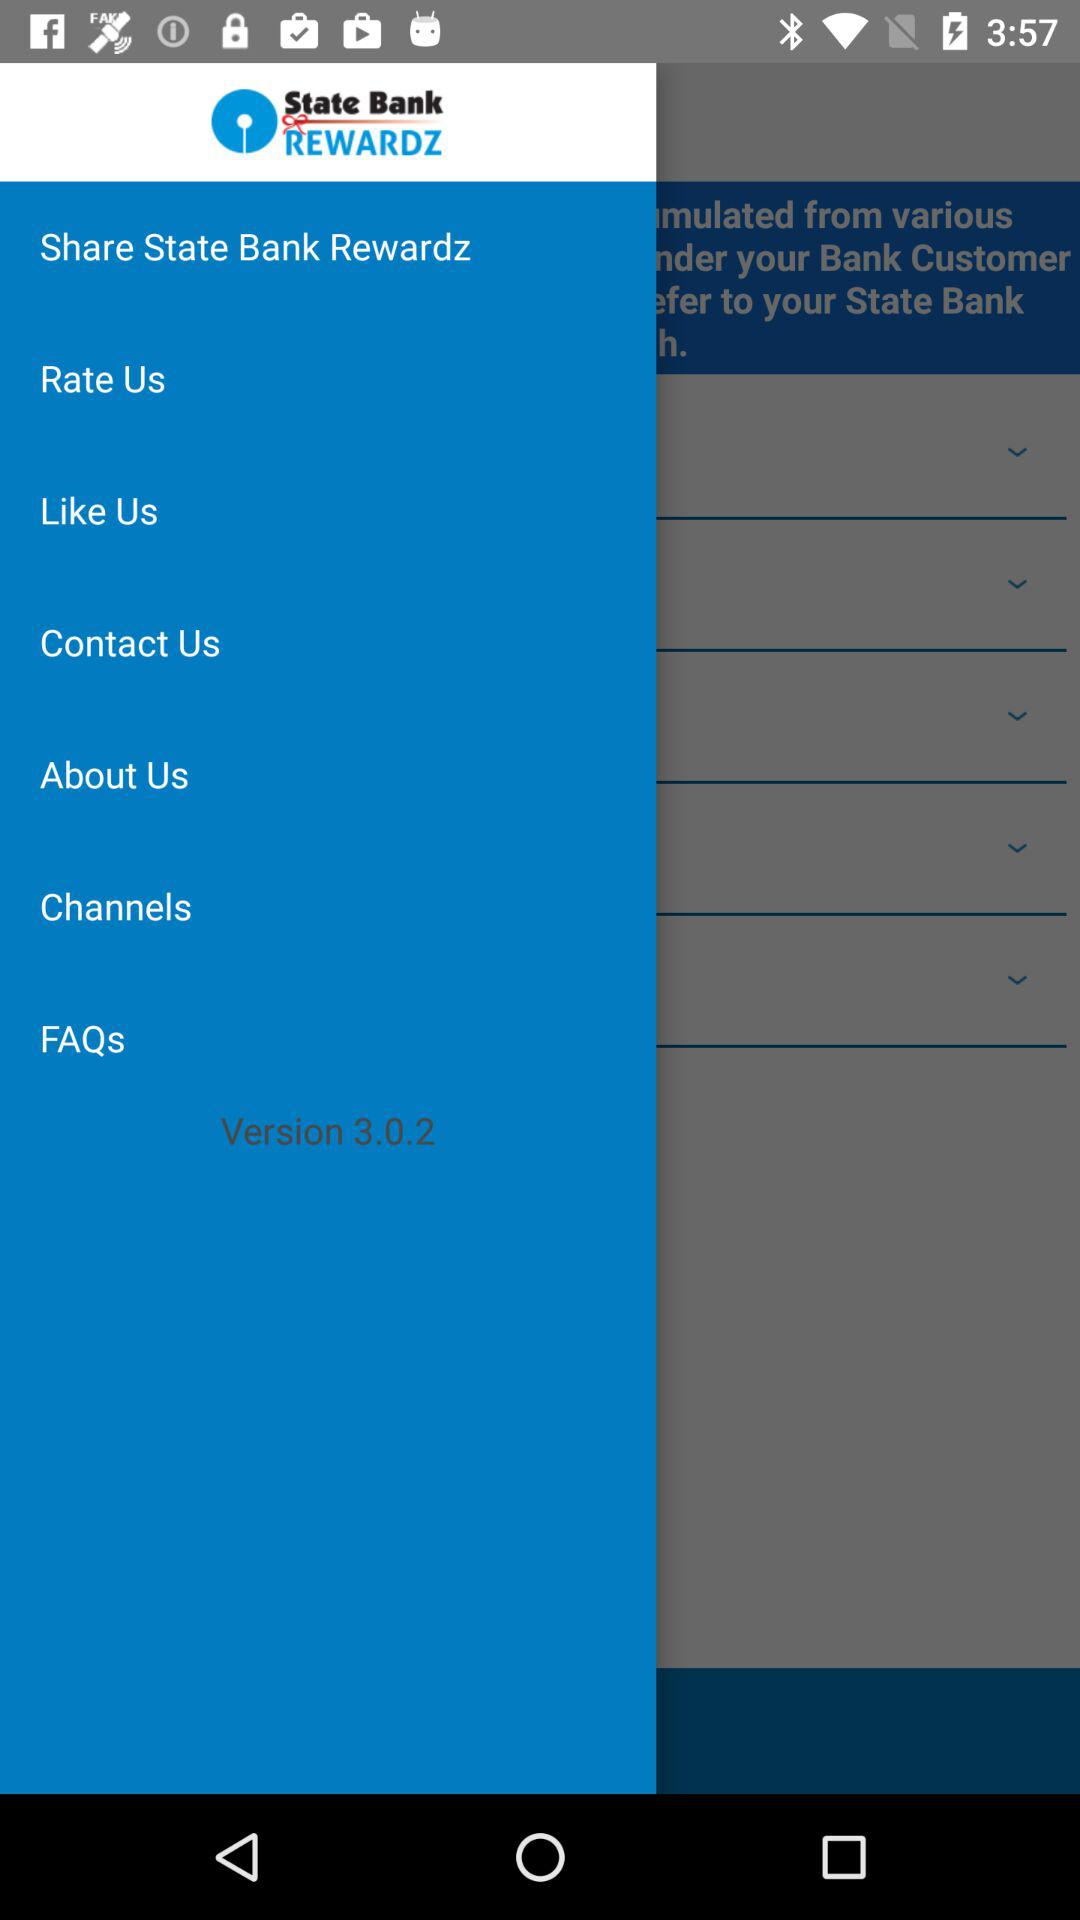What is the version of the app? The version of the app is 3.0.2. 